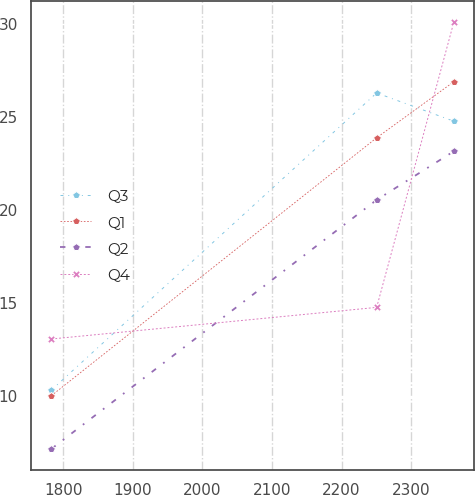<chart> <loc_0><loc_0><loc_500><loc_500><line_chart><ecel><fcel>Q3<fcel>Q1<fcel>Q2<fcel>Q4<nl><fcel>1782.49<fcel>10.34<fcel>10.04<fcel>7.18<fcel>13.09<nl><fcel>2250.6<fcel>26.32<fcel>23.91<fcel>20.57<fcel>14.79<nl><fcel>2361.49<fcel>24.8<fcel>26.92<fcel>23.18<fcel>30.11<nl></chart> 